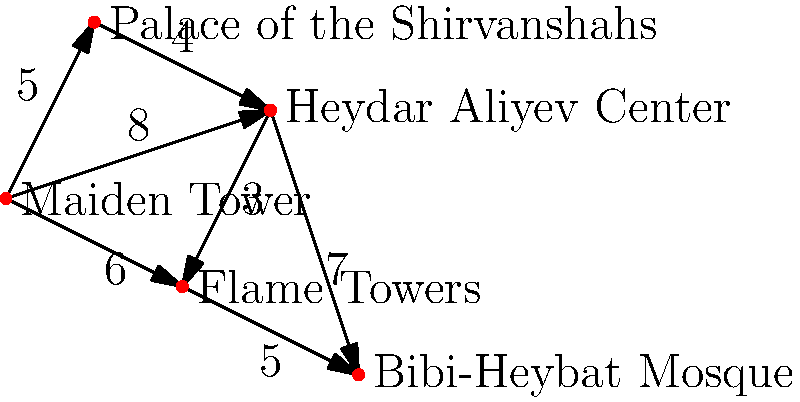Given the weighted graph representing key architectural landmarks in Baku, what is the shortest path from the Maiden Tower to the Bibi-Heybat Mosque, and what is its total distance? To find the shortest path from the Maiden Tower to the Bibi-Heybat Mosque, we'll use Dijkstra's algorithm:

1. Initialize:
   - Set distance to Maiden Tower as 0, all others as infinity.
   - Set all nodes as unvisited.

2. For the current node (starting with Maiden Tower), consider all unvisited neighbors and calculate their tentative distances.
   - To Palace of the Shirvanshahs: 5
   - To Heydar Aliyev Center: 8
   - To Flame Towers: 6

3. Mark Maiden Tower as visited. Palace of the Shirvanshahs has the smallest tentative distance (5), so it becomes the current node.

4. From Palace of the Shirvanshahs:
   - To Heydar Aliyev Center: 5 + 4 = 9 (shorter than current 8, so update)

5. Mark Palace of the Shirvanshahs as visited. Flame Towers has the smallest tentative distance (6), so it becomes the current node.

6. From Flame Towers:
   - To Heydar Aliyev Center: 6 + 3 = 9 (same as current, no update)
   - To Bibi-Heybat Mosque: 6 + 5 = 11

7. Mark Flame Towers as visited. Heydar Aliyev Center becomes the current node (distance 9).

8. From Heydar Aliyev Center:
   - To Bibi-Heybat Mosque: 9 + 7 = 16 (longer than current 11, no update)

9. All nodes visited. Shortest path found: Maiden Tower → Flame Towers → Bibi-Heybat Mosque.

The total distance is 6 + 5 = 11.
Answer: Maiden Tower → Flame Towers → Bibi-Heybat Mosque; 11 units 